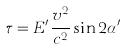<formula> <loc_0><loc_0><loc_500><loc_500>\tau = E ^ { \prime } \frac { v ^ { 2 } } { c ^ { 2 } } \sin 2 \alpha ^ { \prime }</formula> 